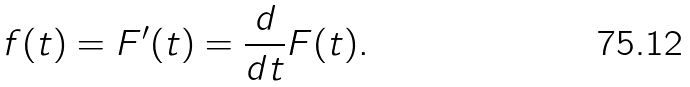<formula> <loc_0><loc_0><loc_500><loc_500>f ( t ) = F ^ { \prime } ( t ) = { \frac { d } { d t } } F ( t ) .</formula> 